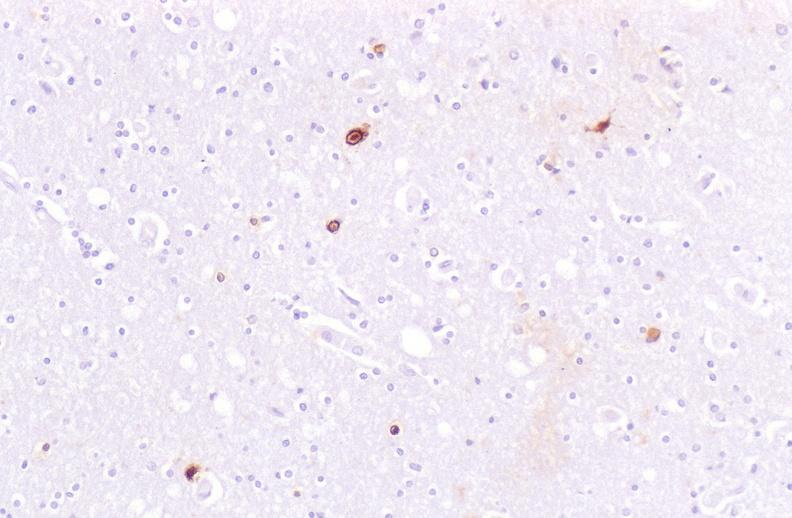what is present?
Answer the question using a single word or phrase. Nervous 